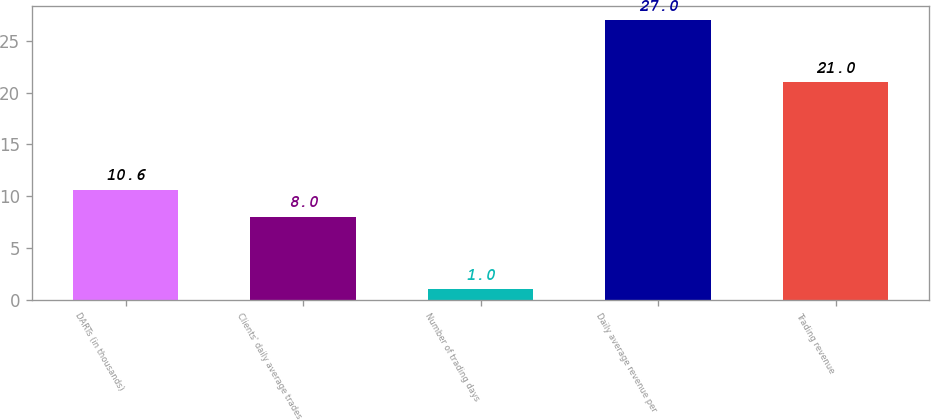Convert chart. <chart><loc_0><loc_0><loc_500><loc_500><bar_chart><fcel>DARTs (in thousands)<fcel>Clients' daily average trades<fcel>Number of trading days<fcel>Daily average revenue per<fcel>Trading revenue<nl><fcel>10.6<fcel>8<fcel>1<fcel>27<fcel>21<nl></chart> 